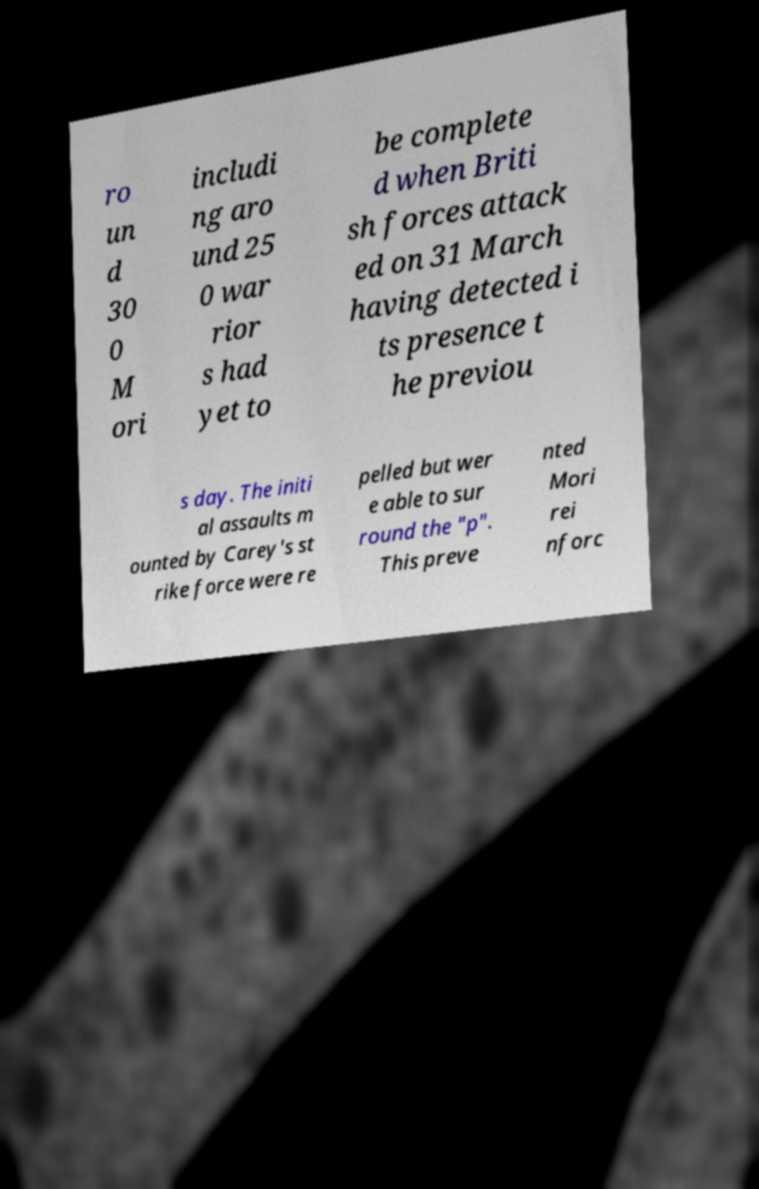Could you assist in decoding the text presented in this image and type it out clearly? ro un d 30 0 M ori includi ng aro und 25 0 war rior s had yet to be complete d when Briti sh forces attack ed on 31 March having detected i ts presence t he previou s day. The initi al assaults m ounted by Carey's st rike force were re pelled but wer e able to sur round the "p". This preve nted Mori rei nforc 